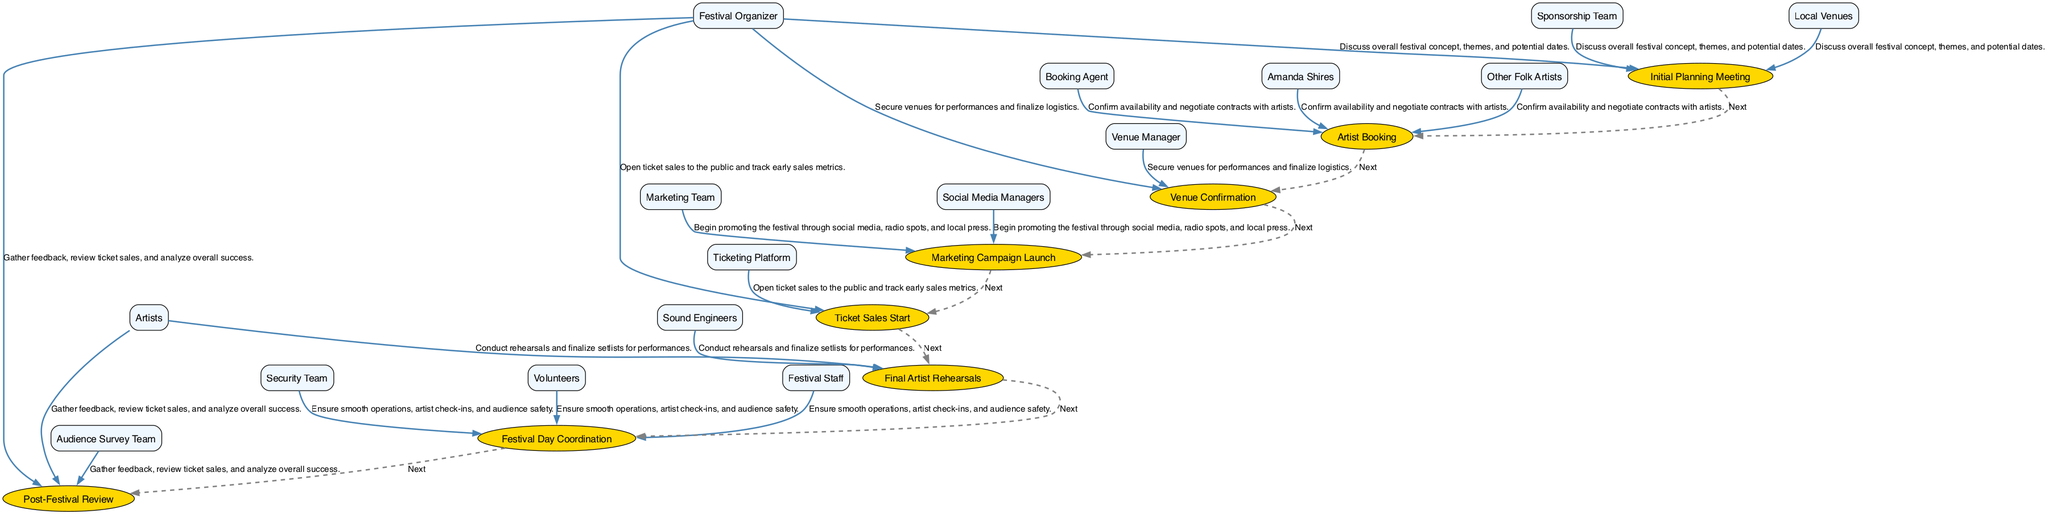What's the first event in the timeline? The first event listed in the data is "Initial Planning Meeting", which is the starting point of the festival planning process.
Answer: Initial Planning Meeting How many total events are there in the timeline? By counting the number of events provided in the data, there are a total of 8 events listed.
Answer: 8 Which stakeholders are involved in the "Artist Booking" event? The stakeholders listed for the "Artist Booking" event are "Booking Agent," "Amanda Shires," and "Other Folk Artists."
Answer: Booking Agent, Amanda Shires, Other Folk Artists What comes after "Venue Confirmation" in the timeline? The event that follows "Venue Confirmation," as indicated by the sequence of events, is "Marketing Campaign Launch."
Answer: Marketing Campaign Launch Who is responsible for the "Post-Festival Review"? The stakeholders involved in the "Post-Festival Review" are "Festival Organizer," "Artists," and "Audience Survey Team," indicating that these groups are responsible for gathering feedback and analyzing success.
Answer: Festival Organizer, Artists, Audience Survey Team How does the "Ticket Sales Start" relate to the previous event? "Ticket Sales Start" follows "Marketing Campaign Launch," which implies that ticket sales are opened after the marketing efforts to promote the festival have begun.
Answer: Followed by Marketing Campaign Launch Which event involves artists rehearsing for performances? The event that involves artists rehearsing is called "Final Artist Rehearsals," where artists and sound engineers work to finalize setlists.
Answer: Final Artist Rehearsals What is the purpose of the "Festival Day Coordination" event? The "Festival Day Coordination" event's purpose is to ensure smooth operations, artist check-ins, and audience safety on the actual festival day.
Answer: Ensure smooth operations, artist check-ins, audience safety What is the relationship between "Initial Planning Meeting" and "Artist Booking"? "Artist Booking" occurs after "Initial Planning Meeting" as the next logical step in the planning process, confirming the festival concept and dates discussed initially.
Answer: Next 